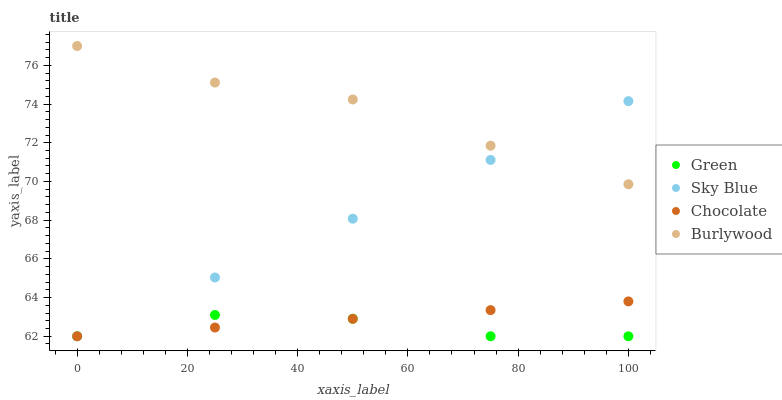Does Green have the minimum area under the curve?
Answer yes or no. Yes. Does Burlywood have the maximum area under the curve?
Answer yes or no. Yes. Does Sky Blue have the minimum area under the curve?
Answer yes or no. No. Does Sky Blue have the maximum area under the curve?
Answer yes or no. No. Is Chocolate the smoothest?
Answer yes or no. Yes. Is Burlywood the roughest?
Answer yes or no. Yes. Is Sky Blue the smoothest?
Answer yes or no. No. Is Sky Blue the roughest?
Answer yes or no. No. Does Sky Blue have the lowest value?
Answer yes or no. Yes. Does Burlywood have the highest value?
Answer yes or no. Yes. Does Sky Blue have the highest value?
Answer yes or no. No. Is Green less than Burlywood?
Answer yes or no. Yes. Is Burlywood greater than Chocolate?
Answer yes or no. Yes. Does Green intersect Chocolate?
Answer yes or no. Yes. Is Green less than Chocolate?
Answer yes or no. No. Is Green greater than Chocolate?
Answer yes or no. No. Does Green intersect Burlywood?
Answer yes or no. No. 